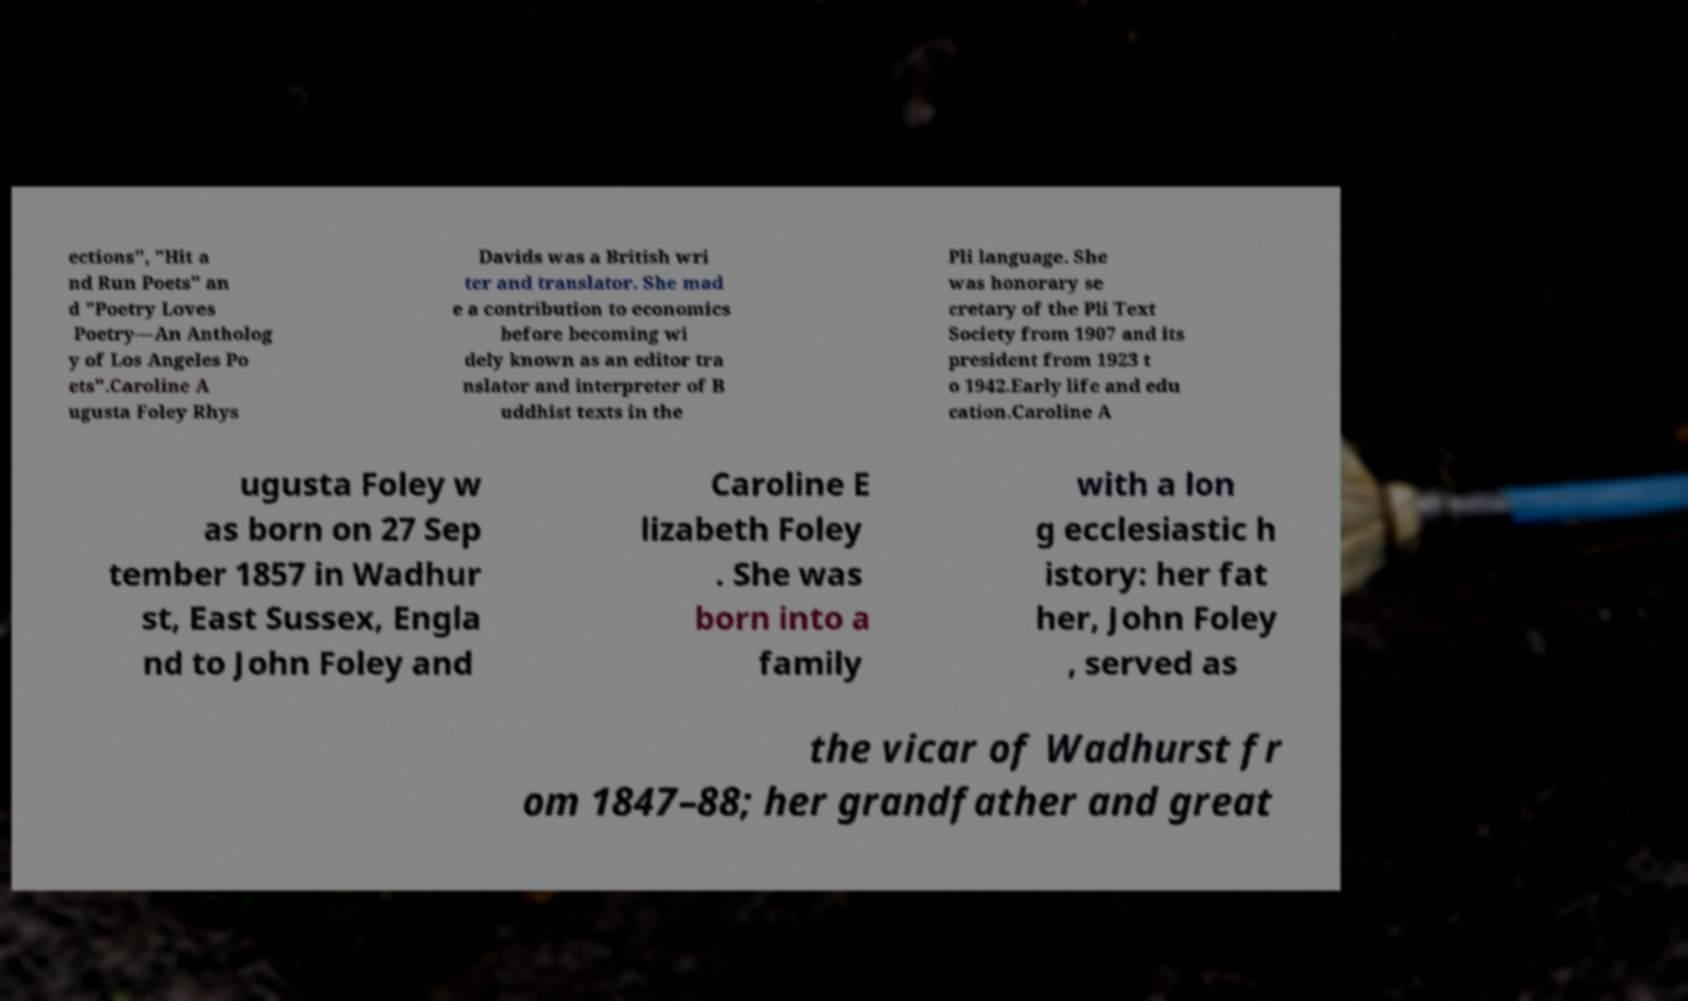Could you assist in decoding the text presented in this image and type it out clearly? ections", "Hit a nd Run Poets" an d "Poetry Loves Poetry—An Antholog y of Los Angeles Po ets".Caroline A ugusta Foley Rhys Davids was a British wri ter and translator. She mad e a contribution to economics before becoming wi dely known as an editor tra nslator and interpreter of B uddhist texts in the Pli language. She was honorary se cretary of the Pli Text Society from 1907 and its president from 1923 t o 1942.Early life and edu cation.Caroline A ugusta Foley w as born on 27 Sep tember 1857 in Wadhur st, East Sussex, Engla nd to John Foley and Caroline E lizabeth Foley . She was born into a family with a lon g ecclesiastic h istory: her fat her, John Foley , served as the vicar of Wadhurst fr om 1847–88; her grandfather and great 